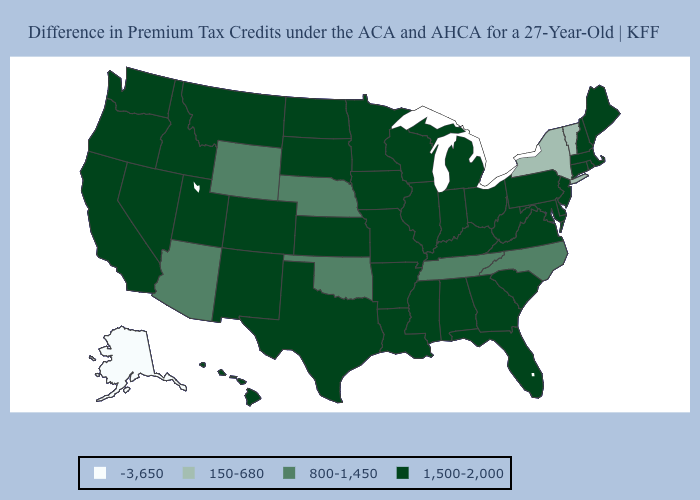Which states have the lowest value in the USA?
Answer briefly. Alaska. Does Hawaii have the same value as Wyoming?
Be succinct. No. What is the highest value in the USA?
Quick response, please. 1,500-2,000. Name the states that have a value in the range -3,650?
Keep it brief. Alaska. Does North Dakota have the same value as New York?
Keep it brief. No. How many symbols are there in the legend?
Quick response, please. 4. How many symbols are there in the legend?
Keep it brief. 4. Which states have the lowest value in the USA?
Concise answer only. Alaska. Name the states that have a value in the range 150-680?
Quick response, please. New York, Vermont. What is the value of New Mexico?
Give a very brief answer. 1,500-2,000. What is the value of Arkansas?
Short answer required. 1,500-2,000. Name the states that have a value in the range 150-680?
Answer briefly. New York, Vermont. What is the value of Oklahoma?
Concise answer only. 800-1,450. What is the value of Virginia?
Short answer required. 1,500-2,000. Name the states that have a value in the range 800-1,450?
Quick response, please. Arizona, Nebraska, North Carolina, Oklahoma, Tennessee, Wyoming. 